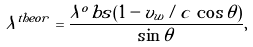Convert formula to latex. <formula><loc_0><loc_0><loc_500><loc_500>\lambda ^ { t h e o r } = \frac { \lambda ^ { o } b s ( 1 - v _ { w } / c \, \cos \theta ) } { \sin \theta } ,</formula> 